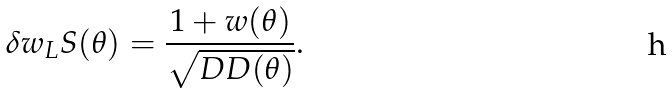Convert formula to latex. <formula><loc_0><loc_0><loc_500><loc_500>\delta w _ { L } S ( \theta ) = \frac { 1 + w ( \theta ) } { \sqrt { D D ( \theta ) } } .</formula> 